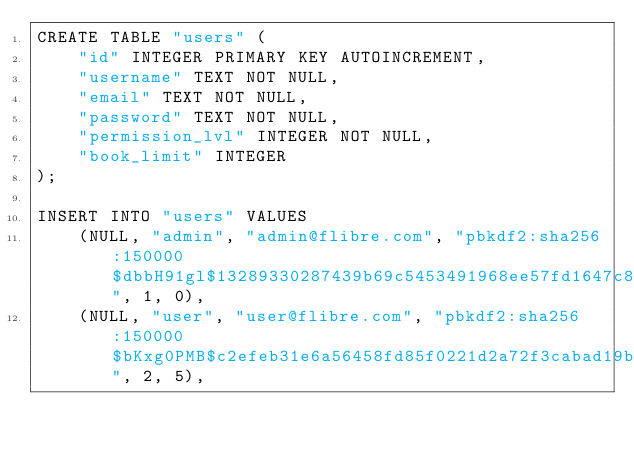<code> <loc_0><loc_0><loc_500><loc_500><_SQL_>CREATE TABLE "users" (
    "id" INTEGER PRIMARY KEY AUTOINCREMENT,
    "username" TEXT NOT NULL,
    "email" TEXT NOT NULL,
    "password" TEXT NOT NULL,
    "permission_lvl" INTEGER NOT NULL,
    "book_limit" INTEGER
);

INSERT INTO "users" VALUES
    (NULL, "admin", "admin@flibre.com", "pbkdf2:sha256:150000$dbbH91gl$13289330287439b69c5453491968ee57fd1647c8c6baeb523243cc4431607d7a", 1, 0),
    (NULL, "user", "user@flibre.com", "pbkdf2:sha256:150000$bKxg0PMB$c2efeb31e6a56458fd85f0221d2a72f3cabad19bc794cc98d43ed9e5e3ba58d2", 2, 5),
</code> 